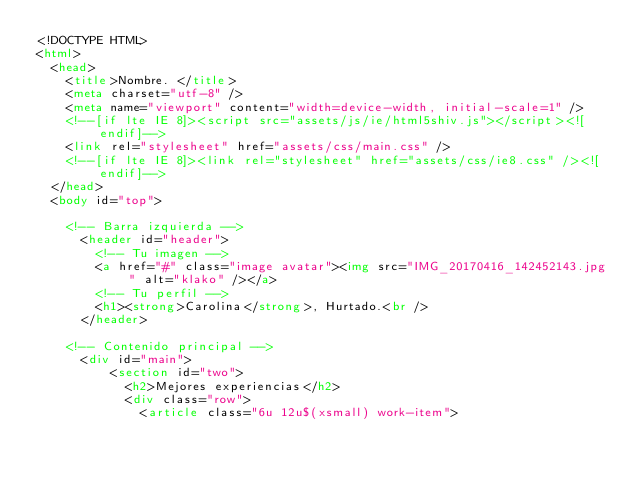Convert code to text. <code><loc_0><loc_0><loc_500><loc_500><_HTML_><!DOCTYPE HTML>
<html>
	<head>
		<title>Nombre. </title>
		<meta charset="utf-8" />
		<meta name="viewport" content="width=device-width, initial-scale=1" />
		<!--[if lte IE 8]><script src="assets/js/ie/html5shiv.js"></script><![endif]-->
		<link rel="stylesheet" href="assets/css/main.css" />
		<!--[if lte IE 8]><link rel="stylesheet" href="assets/css/ie8.css" /><![endif]-->
	</head>
	<body id="top">

		<!-- Barra izquierda -->
			<header id="header">
				<!-- Tu imagen -->
				<a href="#" class="image avatar"><img src="IMG_20170416_142452143.jpg" alt="klako" /></a>
				<!-- Tu perfil -->
				<h1><strong>Carolina</strong>, Hurtado.<br />
			</header>

		<!-- Contenido principal -->
			<div id="main">
					<section id="two">
					  <h2>Mejores experiencias</h2>
					  <div class="row">
					    <article class="6u 12u$(xsmall) work-item"></code> 